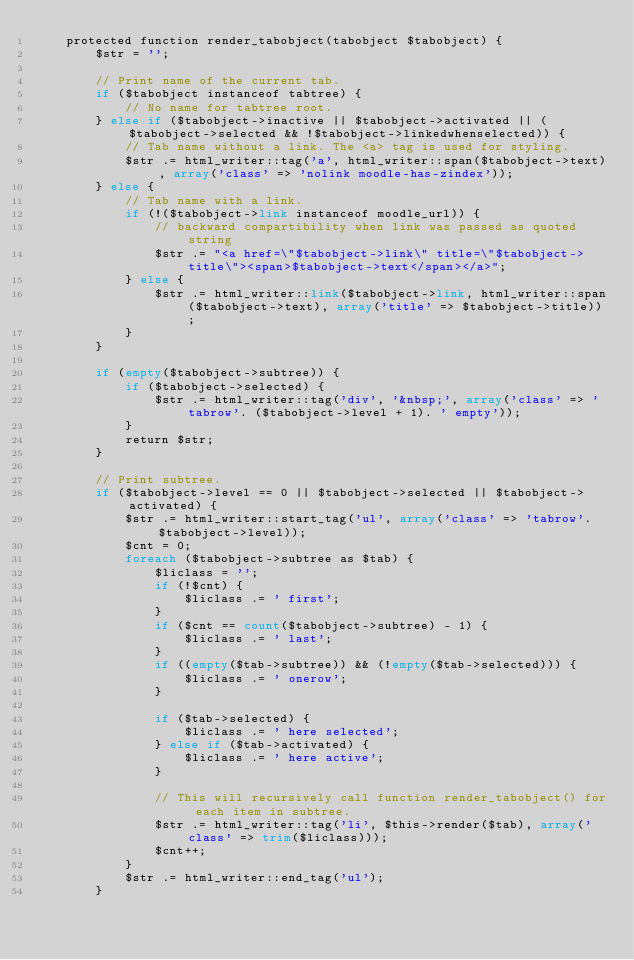<code> <loc_0><loc_0><loc_500><loc_500><_PHP_>    protected function render_tabobject(tabobject $tabobject) {
        $str = '';

        // Print name of the current tab.
        if ($tabobject instanceof tabtree) {
            // No name for tabtree root.
        } else if ($tabobject->inactive || $tabobject->activated || ($tabobject->selected && !$tabobject->linkedwhenselected)) {
            // Tab name without a link. The <a> tag is used for styling.
            $str .= html_writer::tag('a', html_writer::span($tabobject->text), array('class' => 'nolink moodle-has-zindex'));
        } else {
            // Tab name with a link.
            if (!($tabobject->link instanceof moodle_url)) {
                // backward compartibility when link was passed as quoted string
                $str .= "<a href=\"$tabobject->link\" title=\"$tabobject->title\"><span>$tabobject->text</span></a>";
            } else {
                $str .= html_writer::link($tabobject->link, html_writer::span($tabobject->text), array('title' => $tabobject->title));
            }
        }

        if (empty($tabobject->subtree)) {
            if ($tabobject->selected) {
                $str .= html_writer::tag('div', '&nbsp;', array('class' => 'tabrow'. ($tabobject->level + 1). ' empty'));
            }
            return $str;
        }

        // Print subtree.
        if ($tabobject->level == 0 || $tabobject->selected || $tabobject->activated) {
            $str .= html_writer::start_tag('ul', array('class' => 'tabrow'. $tabobject->level));
            $cnt = 0;
            foreach ($tabobject->subtree as $tab) {
                $liclass = '';
                if (!$cnt) {
                    $liclass .= ' first';
                }
                if ($cnt == count($tabobject->subtree) - 1) {
                    $liclass .= ' last';
                }
                if ((empty($tab->subtree)) && (!empty($tab->selected))) {
                    $liclass .= ' onerow';
                }

                if ($tab->selected) {
                    $liclass .= ' here selected';
                } else if ($tab->activated) {
                    $liclass .= ' here active';
                }

                // This will recursively call function render_tabobject() for each item in subtree.
                $str .= html_writer::tag('li', $this->render($tab), array('class' => trim($liclass)));
                $cnt++;
            }
            $str .= html_writer::end_tag('ul');
        }
</code> 